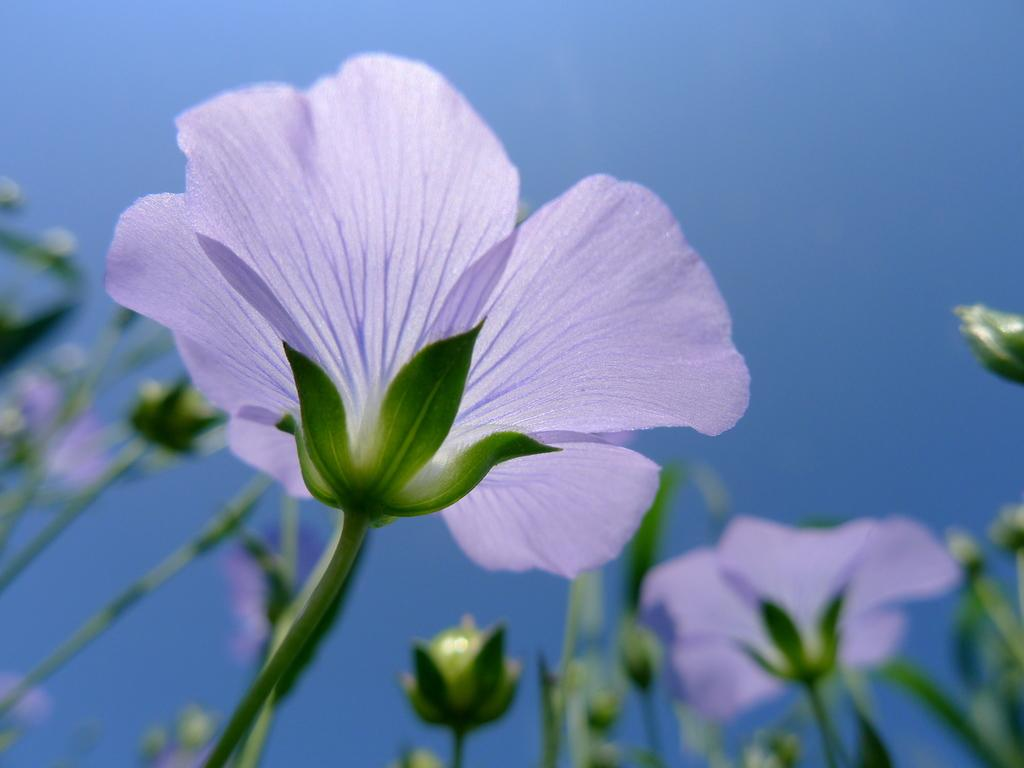What type of living organisms can be seen in the image? Flowers can be seen in the image. How does the flower change its size in the image? Flowers do not change their size in the image; they are static and do not have the ability to change their size. 